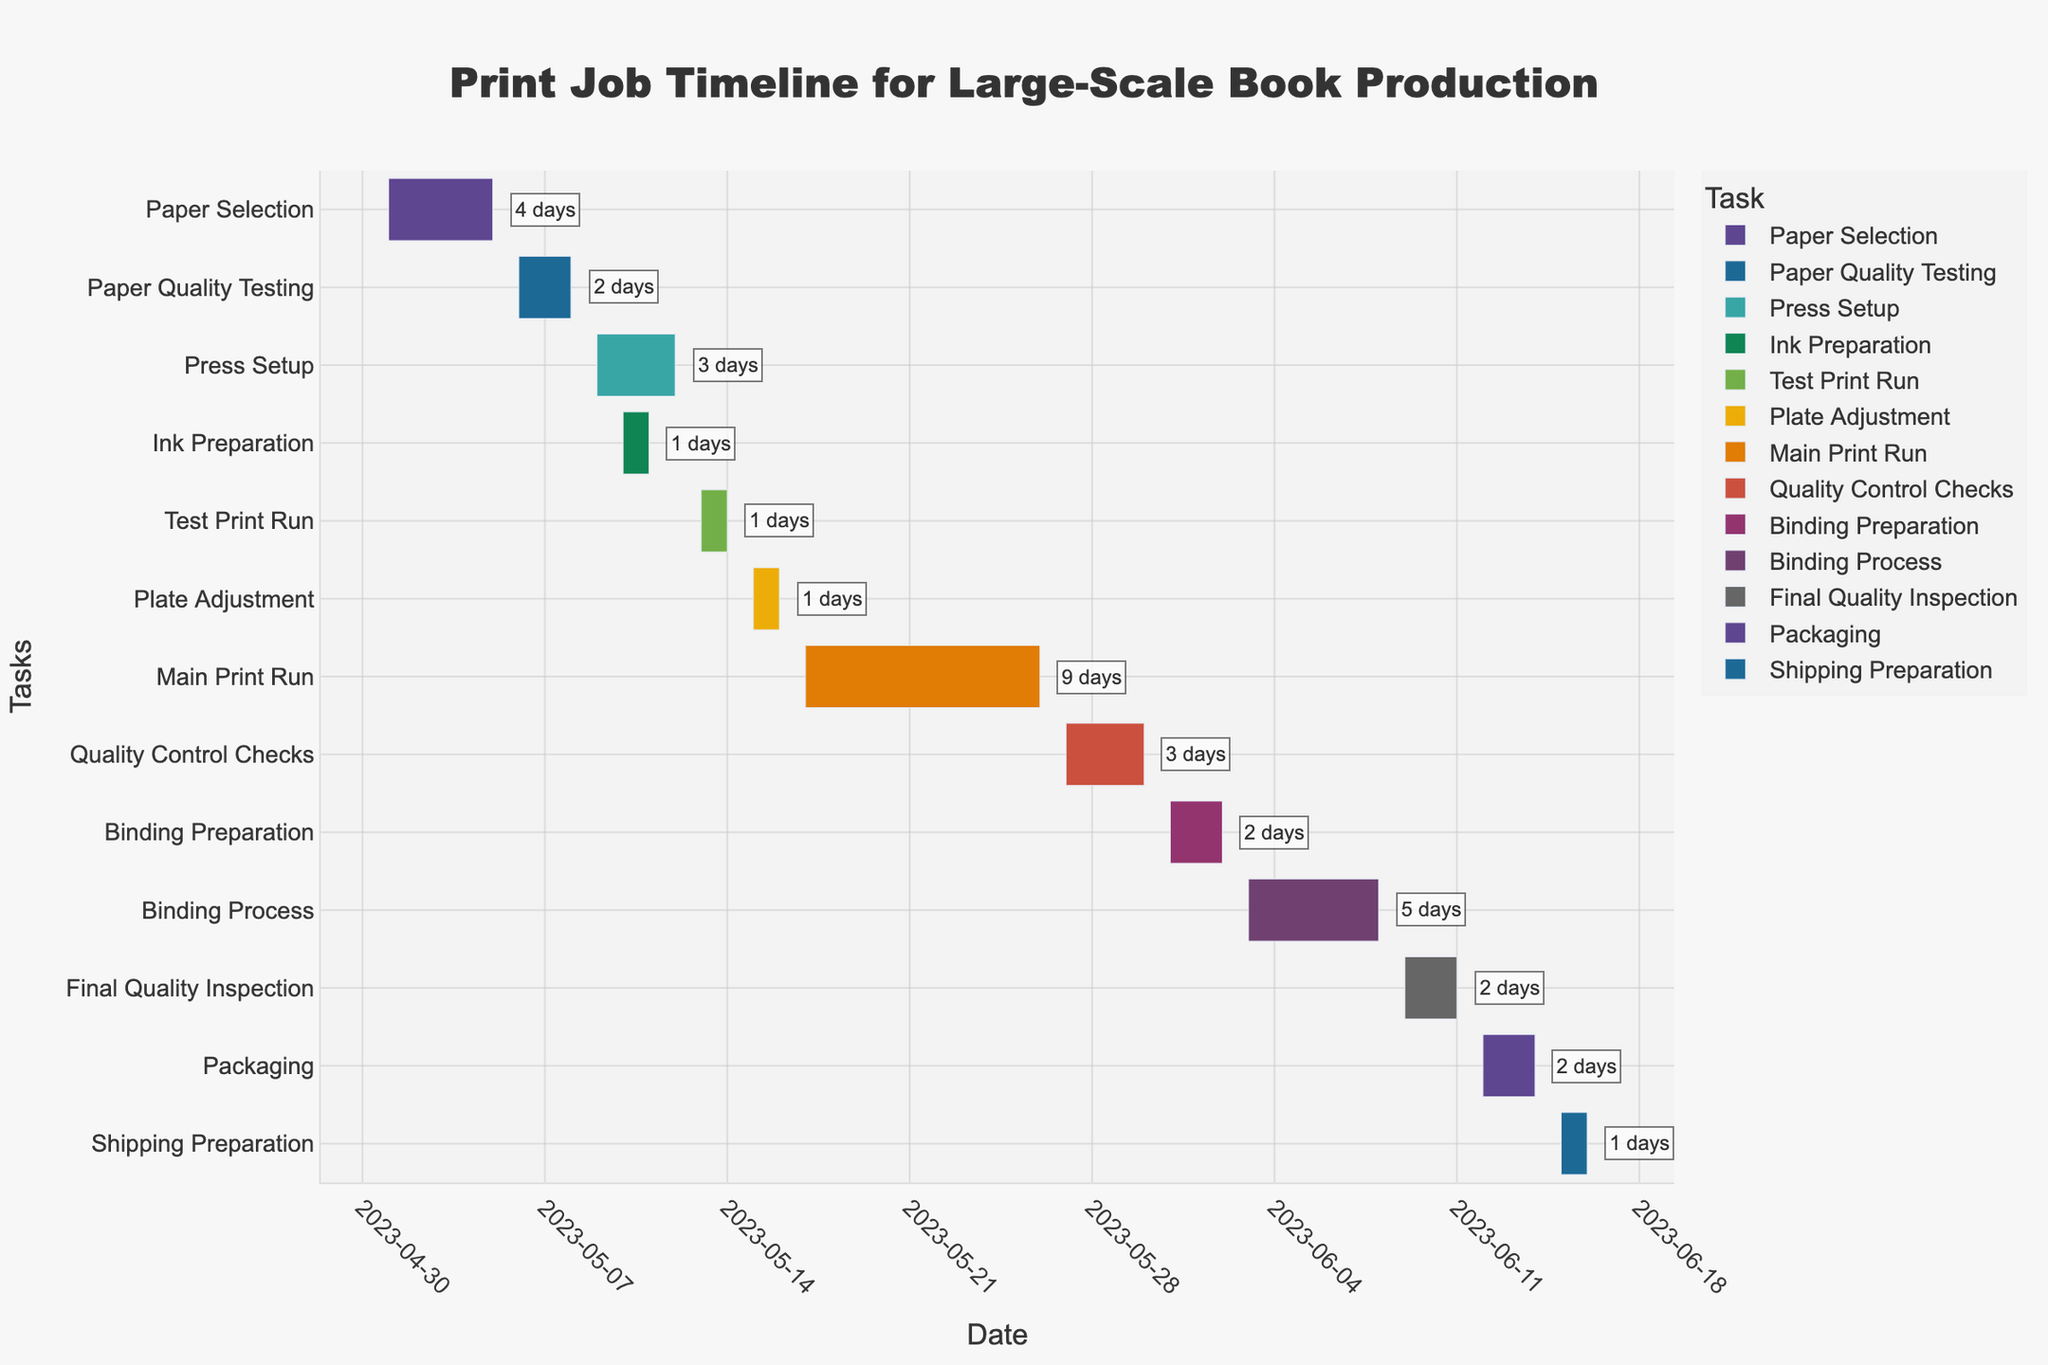What is the title of the Gantt chart? The title is located at the top center of the chart, which contains the text indicating the overall subject of the Gantt chart.
Answer: Print Job Timeline for Large-Scale Book Production Which task lasts the longest? Scan the chart to identify the task with the longest duration bar. The longest duration bar belongs to the task "Main Print Run".
Answer: Main Print Run How many days is the "Paper Selection" phase? The task "Paper Selection" is mentioned in the chart with the duration annotated at the end of its bar. The duration annotated is 4 days.
Answer: 4 days What are the start and end dates for the "Press Setup" task? To find the dates, look for the "Press Setup" task on the chart and check the start and end dates on its corresponding time bar.
Answer: 2023-05-09 to 2023-05-12 Which task starts on 2023-06-12? Locate the date 2023-06-12 on the x-axis and find the task bar that starts at that date. The task bar corresponding to that date is "Packaging".
Answer: Packaging What is the total duration for the "Binding Process"? The "Binding Process" task has a duration annotation next to its bar. The duration is displayed as "6 days".
Answer: 6 days Which phases overlap with the "Ink Preparation" task? Identify the "Ink Preparation" time period and then check which other tasks bars overlap with this period. Both "Press Setup" and "Ink Preparation" have overlapping dates 2023-05-10 to 2023-05-11.
Answer: Press Setup What is the combined duration of "Quality Control Checks" and "Final Quality Inspection"? Look at the duration annotations next to each task. "Quality Control Checks" lasts 4 days and "Final Quality Inspection" lasts 3 days. The combined duration is 4 + 3 = 7 days.
Answer: 7 days Does the "Shipping Preparation" start before or after the "Packaging" task ends? Check the end date of the "Packaging" task and compare it with the start date of the "Shipping Preparation" task. "Packaging" ends on 2023-06-14, and "Shipping Preparation" starts on 2023-06-15, which means it starts after.
Answer: After What tasks are executed concurrently with the "Main Print Run" task? Identify the time span of the "Main Print Run" task and check which other tasks overlap this time span. The "Main Print Run" from 2023-05-17 to 2023-05-26 has no overlapping tasks according to the chart.
Answer: None 